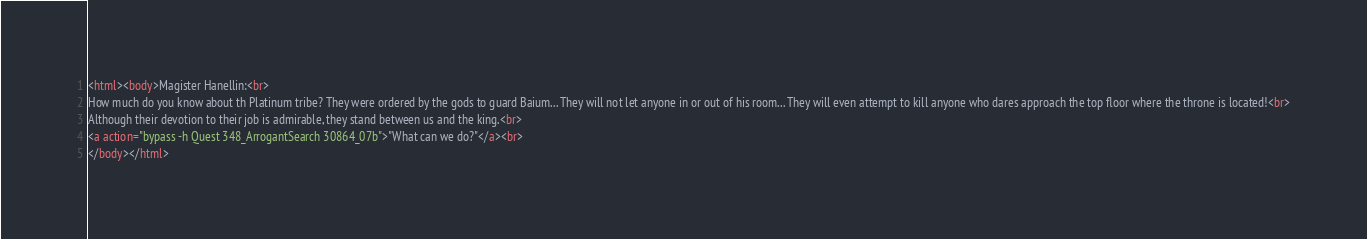<code> <loc_0><loc_0><loc_500><loc_500><_HTML_><html><body>Magister Hanellin:<br>
How much do you know about th Platinum tribe? They were ordered by the gods to guard Baium... They will not let anyone in or out of his room... They will even attempt to kill anyone who dares approach the top floor where the throne is located!<br>
Although their devotion to their job is admirable, they stand between us and the king.<br>
<a action="bypass -h Quest 348_ArrogantSearch 30864_07b">"What can we do?"</a><br>
</body></html></code> 